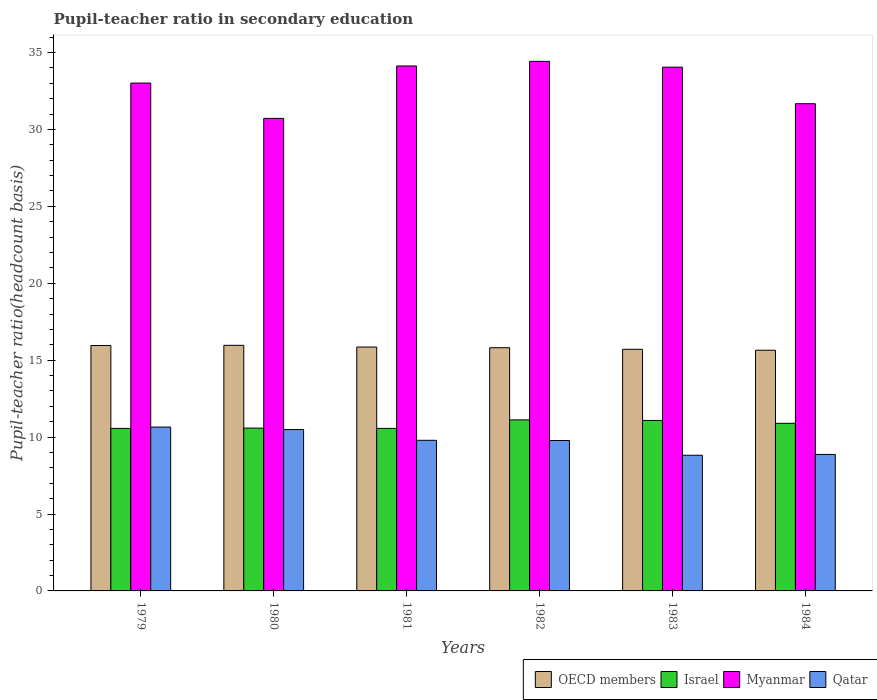Are the number of bars per tick equal to the number of legend labels?
Give a very brief answer. Yes. How many bars are there on the 3rd tick from the left?
Give a very brief answer. 4. What is the label of the 1st group of bars from the left?
Your answer should be compact. 1979. In how many cases, is the number of bars for a given year not equal to the number of legend labels?
Offer a very short reply. 0. What is the pupil-teacher ratio in secondary education in Myanmar in 1983?
Offer a terse response. 34.05. Across all years, what is the maximum pupil-teacher ratio in secondary education in OECD members?
Offer a terse response. 15.97. Across all years, what is the minimum pupil-teacher ratio in secondary education in Israel?
Ensure brevity in your answer.  10.57. What is the total pupil-teacher ratio in secondary education in Myanmar in the graph?
Provide a short and direct response. 198. What is the difference between the pupil-teacher ratio in secondary education in Qatar in 1979 and that in 1980?
Ensure brevity in your answer.  0.16. What is the difference between the pupil-teacher ratio in secondary education in Myanmar in 1983 and the pupil-teacher ratio in secondary education in Israel in 1984?
Provide a succinct answer. 23.15. What is the average pupil-teacher ratio in secondary education in Qatar per year?
Give a very brief answer. 9.73. In the year 1981, what is the difference between the pupil-teacher ratio in secondary education in Qatar and pupil-teacher ratio in secondary education in Myanmar?
Provide a succinct answer. -24.33. What is the ratio of the pupil-teacher ratio in secondary education in Qatar in 1981 to that in 1982?
Give a very brief answer. 1. Is the difference between the pupil-teacher ratio in secondary education in Qatar in 1980 and 1982 greater than the difference between the pupil-teacher ratio in secondary education in Myanmar in 1980 and 1982?
Provide a succinct answer. Yes. What is the difference between the highest and the second highest pupil-teacher ratio in secondary education in OECD members?
Your answer should be compact. 0.01. What is the difference between the highest and the lowest pupil-teacher ratio in secondary education in Myanmar?
Provide a short and direct response. 3.71. In how many years, is the pupil-teacher ratio in secondary education in Myanmar greater than the average pupil-teacher ratio in secondary education in Myanmar taken over all years?
Your answer should be very brief. 4. Is the sum of the pupil-teacher ratio in secondary education in Myanmar in 1980 and 1984 greater than the maximum pupil-teacher ratio in secondary education in OECD members across all years?
Your answer should be very brief. Yes. What does the 1st bar from the left in 1982 represents?
Offer a very short reply. OECD members. What does the 2nd bar from the right in 1983 represents?
Offer a very short reply. Myanmar. How many bars are there?
Offer a very short reply. 24. Are all the bars in the graph horizontal?
Keep it short and to the point. No. How many years are there in the graph?
Your answer should be compact. 6. What is the difference between two consecutive major ticks on the Y-axis?
Offer a very short reply. 5. Does the graph contain grids?
Your answer should be very brief. No. How many legend labels are there?
Offer a terse response. 4. How are the legend labels stacked?
Make the answer very short. Horizontal. What is the title of the graph?
Your answer should be compact. Pupil-teacher ratio in secondary education. What is the label or title of the X-axis?
Offer a terse response. Years. What is the label or title of the Y-axis?
Offer a very short reply. Pupil-teacher ratio(headcount basis). What is the Pupil-teacher ratio(headcount basis) in OECD members in 1979?
Your answer should be compact. 15.95. What is the Pupil-teacher ratio(headcount basis) in Israel in 1979?
Your answer should be compact. 10.57. What is the Pupil-teacher ratio(headcount basis) in Myanmar in 1979?
Make the answer very short. 33.01. What is the Pupil-teacher ratio(headcount basis) in Qatar in 1979?
Keep it short and to the point. 10.65. What is the Pupil-teacher ratio(headcount basis) of OECD members in 1980?
Offer a very short reply. 15.97. What is the Pupil-teacher ratio(headcount basis) in Israel in 1980?
Your response must be concise. 10.59. What is the Pupil-teacher ratio(headcount basis) in Myanmar in 1980?
Give a very brief answer. 30.72. What is the Pupil-teacher ratio(headcount basis) in Qatar in 1980?
Make the answer very short. 10.49. What is the Pupil-teacher ratio(headcount basis) of OECD members in 1981?
Make the answer very short. 15.85. What is the Pupil-teacher ratio(headcount basis) in Israel in 1981?
Your answer should be compact. 10.57. What is the Pupil-teacher ratio(headcount basis) of Myanmar in 1981?
Offer a very short reply. 34.12. What is the Pupil-teacher ratio(headcount basis) of Qatar in 1981?
Provide a succinct answer. 9.79. What is the Pupil-teacher ratio(headcount basis) in OECD members in 1982?
Offer a very short reply. 15.81. What is the Pupil-teacher ratio(headcount basis) of Israel in 1982?
Your response must be concise. 11.12. What is the Pupil-teacher ratio(headcount basis) of Myanmar in 1982?
Make the answer very short. 34.42. What is the Pupil-teacher ratio(headcount basis) of Qatar in 1982?
Your response must be concise. 9.78. What is the Pupil-teacher ratio(headcount basis) in OECD members in 1983?
Offer a terse response. 15.71. What is the Pupil-teacher ratio(headcount basis) in Israel in 1983?
Make the answer very short. 11.08. What is the Pupil-teacher ratio(headcount basis) of Myanmar in 1983?
Make the answer very short. 34.05. What is the Pupil-teacher ratio(headcount basis) in Qatar in 1983?
Ensure brevity in your answer.  8.82. What is the Pupil-teacher ratio(headcount basis) of OECD members in 1984?
Keep it short and to the point. 15.65. What is the Pupil-teacher ratio(headcount basis) of Israel in 1984?
Offer a very short reply. 10.9. What is the Pupil-teacher ratio(headcount basis) of Myanmar in 1984?
Offer a terse response. 31.67. What is the Pupil-teacher ratio(headcount basis) of Qatar in 1984?
Make the answer very short. 8.87. Across all years, what is the maximum Pupil-teacher ratio(headcount basis) of OECD members?
Ensure brevity in your answer.  15.97. Across all years, what is the maximum Pupil-teacher ratio(headcount basis) in Israel?
Provide a succinct answer. 11.12. Across all years, what is the maximum Pupil-teacher ratio(headcount basis) of Myanmar?
Your answer should be very brief. 34.42. Across all years, what is the maximum Pupil-teacher ratio(headcount basis) of Qatar?
Your answer should be very brief. 10.65. Across all years, what is the minimum Pupil-teacher ratio(headcount basis) of OECD members?
Your answer should be very brief. 15.65. Across all years, what is the minimum Pupil-teacher ratio(headcount basis) of Israel?
Offer a terse response. 10.57. Across all years, what is the minimum Pupil-teacher ratio(headcount basis) of Myanmar?
Your answer should be very brief. 30.72. Across all years, what is the minimum Pupil-teacher ratio(headcount basis) of Qatar?
Provide a succinct answer. 8.82. What is the total Pupil-teacher ratio(headcount basis) of OECD members in the graph?
Make the answer very short. 94.94. What is the total Pupil-teacher ratio(headcount basis) in Israel in the graph?
Your answer should be compact. 64.81. What is the total Pupil-teacher ratio(headcount basis) of Myanmar in the graph?
Your answer should be very brief. 198. What is the total Pupil-teacher ratio(headcount basis) in Qatar in the graph?
Offer a very short reply. 58.4. What is the difference between the Pupil-teacher ratio(headcount basis) in OECD members in 1979 and that in 1980?
Offer a terse response. -0.01. What is the difference between the Pupil-teacher ratio(headcount basis) in Israel in 1979 and that in 1980?
Your response must be concise. -0.02. What is the difference between the Pupil-teacher ratio(headcount basis) in Myanmar in 1979 and that in 1980?
Provide a short and direct response. 2.3. What is the difference between the Pupil-teacher ratio(headcount basis) in Qatar in 1979 and that in 1980?
Make the answer very short. 0.16. What is the difference between the Pupil-teacher ratio(headcount basis) of OECD members in 1979 and that in 1981?
Ensure brevity in your answer.  0.1. What is the difference between the Pupil-teacher ratio(headcount basis) in Israel in 1979 and that in 1981?
Your answer should be very brief. -0. What is the difference between the Pupil-teacher ratio(headcount basis) of Myanmar in 1979 and that in 1981?
Your response must be concise. -1.11. What is the difference between the Pupil-teacher ratio(headcount basis) of Qatar in 1979 and that in 1981?
Ensure brevity in your answer.  0.86. What is the difference between the Pupil-teacher ratio(headcount basis) in OECD members in 1979 and that in 1982?
Your answer should be compact. 0.14. What is the difference between the Pupil-teacher ratio(headcount basis) in Israel in 1979 and that in 1982?
Offer a very short reply. -0.55. What is the difference between the Pupil-teacher ratio(headcount basis) of Myanmar in 1979 and that in 1982?
Keep it short and to the point. -1.41. What is the difference between the Pupil-teacher ratio(headcount basis) in Qatar in 1979 and that in 1982?
Ensure brevity in your answer.  0.88. What is the difference between the Pupil-teacher ratio(headcount basis) of OECD members in 1979 and that in 1983?
Provide a succinct answer. 0.25. What is the difference between the Pupil-teacher ratio(headcount basis) of Israel in 1979 and that in 1983?
Your response must be concise. -0.52. What is the difference between the Pupil-teacher ratio(headcount basis) in Myanmar in 1979 and that in 1983?
Make the answer very short. -1.03. What is the difference between the Pupil-teacher ratio(headcount basis) in Qatar in 1979 and that in 1983?
Make the answer very short. 1.83. What is the difference between the Pupil-teacher ratio(headcount basis) of OECD members in 1979 and that in 1984?
Your response must be concise. 0.31. What is the difference between the Pupil-teacher ratio(headcount basis) in Israel in 1979 and that in 1984?
Your answer should be very brief. -0.33. What is the difference between the Pupil-teacher ratio(headcount basis) of Myanmar in 1979 and that in 1984?
Your answer should be compact. 1.34. What is the difference between the Pupil-teacher ratio(headcount basis) in Qatar in 1979 and that in 1984?
Ensure brevity in your answer.  1.78. What is the difference between the Pupil-teacher ratio(headcount basis) in OECD members in 1980 and that in 1981?
Ensure brevity in your answer.  0.11. What is the difference between the Pupil-teacher ratio(headcount basis) of Israel in 1980 and that in 1981?
Provide a short and direct response. 0.02. What is the difference between the Pupil-teacher ratio(headcount basis) in Myanmar in 1980 and that in 1981?
Offer a terse response. -3.41. What is the difference between the Pupil-teacher ratio(headcount basis) of Qatar in 1980 and that in 1981?
Your response must be concise. 0.7. What is the difference between the Pupil-teacher ratio(headcount basis) of OECD members in 1980 and that in 1982?
Provide a succinct answer. 0.15. What is the difference between the Pupil-teacher ratio(headcount basis) in Israel in 1980 and that in 1982?
Your answer should be very brief. -0.53. What is the difference between the Pupil-teacher ratio(headcount basis) of Myanmar in 1980 and that in 1982?
Your answer should be compact. -3.71. What is the difference between the Pupil-teacher ratio(headcount basis) in Qatar in 1980 and that in 1982?
Ensure brevity in your answer.  0.71. What is the difference between the Pupil-teacher ratio(headcount basis) in OECD members in 1980 and that in 1983?
Your answer should be compact. 0.26. What is the difference between the Pupil-teacher ratio(headcount basis) of Israel in 1980 and that in 1983?
Give a very brief answer. -0.5. What is the difference between the Pupil-teacher ratio(headcount basis) in Myanmar in 1980 and that in 1983?
Provide a succinct answer. -3.33. What is the difference between the Pupil-teacher ratio(headcount basis) in Qatar in 1980 and that in 1983?
Ensure brevity in your answer.  1.67. What is the difference between the Pupil-teacher ratio(headcount basis) of OECD members in 1980 and that in 1984?
Your response must be concise. 0.32. What is the difference between the Pupil-teacher ratio(headcount basis) in Israel in 1980 and that in 1984?
Provide a succinct answer. -0.31. What is the difference between the Pupil-teacher ratio(headcount basis) of Myanmar in 1980 and that in 1984?
Offer a terse response. -0.95. What is the difference between the Pupil-teacher ratio(headcount basis) in Qatar in 1980 and that in 1984?
Make the answer very short. 1.62. What is the difference between the Pupil-teacher ratio(headcount basis) in OECD members in 1981 and that in 1982?
Ensure brevity in your answer.  0.04. What is the difference between the Pupil-teacher ratio(headcount basis) in Israel in 1981 and that in 1982?
Make the answer very short. -0.55. What is the difference between the Pupil-teacher ratio(headcount basis) of Myanmar in 1981 and that in 1982?
Provide a short and direct response. -0.3. What is the difference between the Pupil-teacher ratio(headcount basis) in Qatar in 1981 and that in 1982?
Ensure brevity in your answer.  0.01. What is the difference between the Pupil-teacher ratio(headcount basis) of OECD members in 1981 and that in 1983?
Your answer should be compact. 0.15. What is the difference between the Pupil-teacher ratio(headcount basis) of Israel in 1981 and that in 1983?
Keep it short and to the point. -0.52. What is the difference between the Pupil-teacher ratio(headcount basis) of Myanmar in 1981 and that in 1983?
Offer a very short reply. 0.08. What is the difference between the Pupil-teacher ratio(headcount basis) in Qatar in 1981 and that in 1983?
Give a very brief answer. 0.97. What is the difference between the Pupil-teacher ratio(headcount basis) of OECD members in 1981 and that in 1984?
Your answer should be very brief. 0.21. What is the difference between the Pupil-teacher ratio(headcount basis) in Israel in 1981 and that in 1984?
Your answer should be very brief. -0.33. What is the difference between the Pupil-teacher ratio(headcount basis) in Myanmar in 1981 and that in 1984?
Make the answer very short. 2.45. What is the difference between the Pupil-teacher ratio(headcount basis) of Qatar in 1981 and that in 1984?
Your answer should be very brief. 0.92. What is the difference between the Pupil-teacher ratio(headcount basis) in OECD members in 1982 and that in 1983?
Offer a terse response. 0.1. What is the difference between the Pupil-teacher ratio(headcount basis) of Israel in 1982 and that in 1983?
Your answer should be very brief. 0.04. What is the difference between the Pupil-teacher ratio(headcount basis) of Myanmar in 1982 and that in 1983?
Make the answer very short. 0.38. What is the difference between the Pupil-teacher ratio(headcount basis) in Qatar in 1982 and that in 1983?
Provide a succinct answer. 0.96. What is the difference between the Pupil-teacher ratio(headcount basis) in OECD members in 1982 and that in 1984?
Give a very brief answer. 0.16. What is the difference between the Pupil-teacher ratio(headcount basis) of Israel in 1982 and that in 1984?
Your answer should be compact. 0.22. What is the difference between the Pupil-teacher ratio(headcount basis) in Myanmar in 1982 and that in 1984?
Your response must be concise. 2.75. What is the difference between the Pupil-teacher ratio(headcount basis) in Qatar in 1982 and that in 1984?
Ensure brevity in your answer.  0.9. What is the difference between the Pupil-teacher ratio(headcount basis) of OECD members in 1983 and that in 1984?
Offer a very short reply. 0.06. What is the difference between the Pupil-teacher ratio(headcount basis) in Israel in 1983 and that in 1984?
Provide a short and direct response. 0.19. What is the difference between the Pupil-teacher ratio(headcount basis) in Myanmar in 1983 and that in 1984?
Your response must be concise. 2.38. What is the difference between the Pupil-teacher ratio(headcount basis) of Qatar in 1983 and that in 1984?
Offer a terse response. -0.05. What is the difference between the Pupil-teacher ratio(headcount basis) of OECD members in 1979 and the Pupil-teacher ratio(headcount basis) of Israel in 1980?
Your response must be concise. 5.37. What is the difference between the Pupil-teacher ratio(headcount basis) of OECD members in 1979 and the Pupil-teacher ratio(headcount basis) of Myanmar in 1980?
Your answer should be very brief. -14.77. What is the difference between the Pupil-teacher ratio(headcount basis) in OECD members in 1979 and the Pupil-teacher ratio(headcount basis) in Qatar in 1980?
Provide a succinct answer. 5.46. What is the difference between the Pupil-teacher ratio(headcount basis) in Israel in 1979 and the Pupil-teacher ratio(headcount basis) in Myanmar in 1980?
Your response must be concise. -20.15. What is the difference between the Pupil-teacher ratio(headcount basis) in Israel in 1979 and the Pupil-teacher ratio(headcount basis) in Qatar in 1980?
Offer a terse response. 0.08. What is the difference between the Pupil-teacher ratio(headcount basis) in Myanmar in 1979 and the Pupil-teacher ratio(headcount basis) in Qatar in 1980?
Offer a terse response. 22.52. What is the difference between the Pupil-teacher ratio(headcount basis) of OECD members in 1979 and the Pupil-teacher ratio(headcount basis) of Israel in 1981?
Ensure brevity in your answer.  5.39. What is the difference between the Pupil-teacher ratio(headcount basis) in OECD members in 1979 and the Pupil-teacher ratio(headcount basis) in Myanmar in 1981?
Give a very brief answer. -18.17. What is the difference between the Pupil-teacher ratio(headcount basis) in OECD members in 1979 and the Pupil-teacher ratio(headcount basis) in Qatar in 1981?
Your answer should be compact. 6.16. What is the difference between the Pupil-teacher ratio(headcount basis) of Israel in 1979 and the Pupil-teacher ratio(headcount basis) of Myanmar in 1981?
Offer a terse response. -23.56. What is the difference between the Pupil-teacher ratio(headcount basis) of Israel in 1979 and the Pupil-teacher ratio(headcount basis) of Qatar in 1981?
Make the answer very short. 0.77. What is the difference between the Pupil-teacher ratio(headcount basis) of Myanmar in 1979 and the Pupil-teacher ratio(headcount basis) of Qatar in 1981?
Your answer should be compact. 23.22. What is the difference between the Pupil-teacher ratio(headcount basis) in OECD members in 1979 and the Pupil-teacher ratio(headcount basis) in Israel in 1982?
Your response must be concise. 4.84. What is the difference between the Pupil-teacher ratio(headcount basis) in OECD members in 1979 and the Pupil-teacher ratio(headcount basis) in Myanmar in 1982?
Your answer should be very brief. -18.47. What is the difference between the Pupil-teacher ratio(headcount basis) of OECD members in 1979 and the Pupil-teacher ratio(headcount basis) of Qatar in 1982?
Your response must be concise. 6.18. What is the difference between the Pupil-teacher ratio(headcount basis) of Israel in 1979 and the Pupil-teacher ratio(headcount basis) of Myanmar in 1982?
Ensure brevity in your answer.  -23.86. What is the difference between the Pupil-teacher ratio(headcount basis) of Israel in 1979 and the Pupil-teacher ratio(headcount basis) of Qatar in 1982?
Provide a succinct answer. 0.79. What is the difference between the Pupil-teacher ratio(headcount basis) of Myanmar in 1979 and the Pupil-teacher ratio(headcount basis) of Qatar in 1982?
Your answer should be compact. 23.24. What is the difference between the Pupil-teacher ratio(headcount basis) of OECD members in 1979 and the Pupil-teacher ratio(headcount basis) of Israel in 1983?
Provide a succinct answer. 4.87. What is the difference between the Pupil-teacher ratio(headcount basis) of OECD members in 1979 and the Pupil-teacher ratio(headcount basis) of Myanmar in 1983?
Provide a short and direct response. -18.09. What is the difference between the Pupil-teacher ratio(headcount basis) in OECD members in 1979 and the Pupil-teacher ratio(headcount basis) in Qatar in 1983?
Keep it short and to the point. 7.13. What is the difference between the Pupil-teacher ratio(headcount basis) of Israel in 1979 and the Pupil-teacher ratio(headcount basis) of Myanmar in 1983?
Make the answer very short. -23.48. What is the difference between the Pupil-teacher ratio(headcount basis) in Israel in 1979 and the Pupil-teacher ratio(headcount basis) in Qatar in 1983?
Offer a terse response. 1.75. What is the difference between the Pupil-teacher ratio(headcount basis) of Myanmar in 1979 and the Pupil-teacher ratio(headcount basis) of Qatar in 1983?
Offer a terse response. 24.2. What is the difference between the Pupil-teacher ratio(headcount basis) of OECD members in 1979 and the Pupil-teacher ratio(headcount basis) of Israel in 1984?
Give a very brief answer. 5.06. What is the difference between the Pupil-teacher ratio(headcount basis) of OECD members in 1979 and the Pupil-teacher ratio(headcount basis) of Myanmar in 1984?
Offer a very short reply. -15.72. What is the difference between the Pupil-teacher ratio(headcount basis) in OECD members in 1979 and the Pupil-teacher ratio(headcount basis) in Qatar in 1984?
Provide a short and direct response. 7.08. What is the difference between the Pupil-teacher ratio(headcount basis) in Israel in 1979 and the Pupil-teacher ratio(headcount basis) in Myanmar in 1984?
Your answer should be compact. -21.11. What is the difference between the Pupil-teacher ratio(headcount basis) of Israel in 1979 and the Pupil-teacher ratio(headcount basis) of Qatar in 1984?
Your answer should be very brief. 1.69. What is the difference between the Pupil-teacher ratio(headcount basis) of Myanmar in 1979 and the Pupil-teacher ratio(headcount basis) of Qatar in 1984?
Ensure brevity in your answer.  24.14. What is the difference between the Pupil-teacher ratio(headcount basis) in OECD members in 1980 and the Pupil-teacher ratio(headcount basis) in Israel in 1981?
Offer a very short reply. 5.4. What is the difference between the Pupil-teacher ratio(headcount basis) in OECD members in 1980 and the Pupil-teacher ratio(headcount basis) in Myanmar in 1981?
Ensure brevity in your answer.  -18.16. What is the difference between the Pupil-teacher ratio(headcount basis) of OECD members in 1980 and the Pupil-teacher ratio(headcount basis) of Qatar in 1981?
Give a very brief answer. 6.17. What is the difference between the Pupil-teacher ratio(headcount basis) in Israel in 1980 and the Pupil-teacher ratio(headcount basis) in Myanmar in 1981?
Offer a very short reply. -23.54. What is the difference between the Pupil-teacher ratio(headcount basis) of Israel in 1980 and the Pupil-teacher ratio(headcount basis) of Qatar in 1981?
Offer a very short reply. 0.79. What is the difference between the Pupil-teacher ratio(headcount basis) in Myanmar in 1980 and the Pupil-teacher ratio(headcount basis) in Qatar in 1981?
Offer a terse response. 20.93. What is the difference between the Pupil-teacher ratio(headcount basis) of OECD members in 1980 and the Pupil-teacher ratio(headcount basis) of Israel in 1982?
Provide a succinct answer. 4.85. What is the difference between the Pupil-teacher ratio(headcount basis) in OECD members in 1980 and the Pupil-teacher ratio(headcount basis) in Myanmar in 1982?
Your answer should be compact. -18.46. What is the difference between the Pupil-teacher ratio(headcount basis) in OECD members in 1980 and the Pupil-teacher ratio(headcount basis) in Qatar in 1982?
Provide a short and direct response. 6.19. What is the difference between the Pupil-teacher ratio(headcount basis) of Israel in 1980 and the Pupil-teacher ratio(headcount basis) of Myanmar in 1982?
Offer a very short reply. -23.84. What is the difference between the Pupil-teacher ratio(headcount basis) in Israel in 1980 and the Pupil-teacher ratio(headcount basis) in Qatar in 1982?
Provide a succinct answer. 0.81. What is the difference between the Pupil-teacher ratio(headcount basis) of Myanmar in 1980 and the Pupil-teacher ratio(headcount basis) of Qatar in 1982?
Your response must be concise. 20.94. What is the difference between the Pupil-teacher ratio(headcount basis) of OECD members in 1980 and the Pupil-teacher ratio(headcount basis) of Israel in 1983?
Ensure brevity in your answer.  4.88. What is the difference between the Pupil-teacher ratio(headcount basis) in OECD members in 1980 and the Pupil-teacher ratio(headcount basis) in Myanmar in 1983?
Keep it short and to the point. -18.08. What is the difference between the Pupil-teacher ratio(headcount basis) of OECD members in 1980 and the Pupil-teacher ratio(headcount basis) of Qatar in 1983?
Your response must be concise. 7.15. What is the difference between the Pupil-teacher ratio(headcount basis) of Israel in 1980 and the Pupil-teacher ratio(headcount basis) of Myanmar in 1983?
Offer a very short reply. -23.46. What is the difference between the Pupil-teacher ratio(headcount basis) of Israel in 1980 and the Pupil-teacher ratio(headcount basis) of Qatar in 1983?
Keep it short and to the point. 1.77. What is the difference between the Pupil-teacher ratio(headcount basis) in Myanmar in 1980 and the Pupil-teacher ratio(headcount basis) in Qatar in 1983?
Your answer should be very brief. 21.9. What is the difference between the Pupil-teacher ratio(headcount basis) of OECD members in 1980 and the Pupil-teacher ratio(headcount basis) of Israel in 1984?
Provide a short and direct response. 5.07. What is the difference between the Pupil-teacher ratio(headcount basis) in OECD members in 1980 and the Pupil-teacher ratio(headcount basis) in Myanmar in 1984?
Your answer should be compact. -15.71. What is the difference between the Pupil-teacher ratio(headcount basis) in OECD members in 1980 and the Pupil-teacher ratio(headcount basis) in Qatar in 1984?
Offer a terse response. 7.09. What is the difference between the Pupil-teacher ratio(headcount basis) of Israel in 1980 and the Pupil-teacher ratio(headcount basis) of Myanmar in 1984?
Provide a succinct answer. -21.09. What is the difference between the Pupil-teacher ratio(headcount basis) in Israel in 1980 and the Pupil-teacher ratio(headcount basis) in Qatar in 1984?
Ensure brevity in your answer.  1.71. What is the difference between the Pupil-teacher ratio(headcount basis) of Myanmar in 1980 and the Pupil-teacher ratio(headcount basis) of Qatar in 1984?
Provide a succinct answer. 21.85. What is the difference between the Pupil-teacher ratio(headcount basis) in OECD members in 1981 and the Pupil-teacher ratio(headcount basis) in Israel in 1982?
Provide a short and direct response. 4.74. What is the difference between the Pupil-teacher ratio(headcount basis) of OECD members in 1981 and the Pupil-teacher ratio(headcount basis) of Myanmar in 1982?
Give a very brief answer. -18.57. What is the difference between the Pupil-teacher ratio(headcount basis) in OECD members in 1981 and the Pupil-teacher ratio(headcount basis) in Qatar in 1982?
Your answer should be compact. 6.08. What is the difference between the Pupil-teacher ratio(headcount basis) of Israel in 1981 and the Pupil-teacher ratio(headcount basis) of Myanmar in 1982?
Your answer should be compact. -23.86. What is the difference between the Pupil-teacher ratio(headcount basis) of Israel in 1981 and the Pupil-teacher ratio(headcount basis) of Qatar in 1982?
Make the answer very short. 0.79. What is the difference between the Pupil-teacher ratio(headcount basis) in Myanmar in 1981 and the Pupil-teacher ratio(headcount basis) in Qatar in 1982?
Offer a terse response. 24.35. What is the difference between the Pupil-teacher ratio(headcount basis) in OECD members in 1981 and the Pupil-teacher ratio(headcount basis) in Israel in 1983?
Offer a very short reply. 4.77. What is the difference between the Pupil-teacher ratio(headcount basis) of OECD members in 1981 and the Pupil-teacher ratio(headcount basis) of Myanmar in 1983?
Make the answer very short. -18.19. What is the difference between the Pupil-teacher ratio(headcount basis) of OECD members in 1981 and the Pupil-teacher ratio(headcount basis) of Qatar in 1983?
Provide a succinct answer. 7.04. What is the difference between the Pupil-teacher ratio(headcount basis) of Israel in 1981 and the Pupil-teacher ratio(headcount basis) of Myanmar in 1983?
Your answer should be very brief. -23.48. What is the difference between the Pupil-teacher ratio(headcount basis) in Israel in 1981 and the Pupil-teacher ratio(headcount basis) in Qatar in 1983?
Your answer should be compact. 1.75. What is the difference between the Pupil-teacher ratio(headcount basis) of Myanmar in 1981 and the Pupil-teacher ratio(headcount basis) of Qatar in 1983?
Give a very brief answer. 25.3. What is the difference between the Pupil-teacher ratio(headcount basis) of OECD members in 1981 and the Pupil-teacher ratio(headcount basis) of Israel in 1984?
Your response must be concise. 4.96. What is the difference between the Pupil-teacher ratio(headcount basis) of OECD members in 1981 and the Pupil-teacher ratio(headcount basis) of Myanmar in 1984?
Your response must be concise. -15.82. What is the difference between the Pupil-teacher ratio(headcount basis) of OECD members in 1981 and the Pupil-teacher ratio(headcount basis) of Qatar in 1984?
Keep it short and to the point. 6.98. What is the difference between the Pupil-teacher ratio(headcount basis) in Israel in 1981 and the Pupil-teacher ratio(headcount basis) in Myanmar in 1984?
Provide a short and direct response. -21.11. What is the difference between the Pupil-teacher ratio(headcount basis) of Israel in 1981 and the Pupil-teacher ratio(headcount basis) of Qatar in 1984?
Provide a short and direct response. 1.69. What is the difference between the Pupil-teacher ratio(headcount basis) in Myanmar in 1981 and the Pupil-teacher ratio(headcount basis) in Qatar in 1984?
Your answer should be compact. 25.25. What is the difference between the Pupil-teacher ratio(headcount basis) of OECD members in 1982 and the Pupil-teacher ratio(headcount basis) of Israel in 1983?
Offer a terse response. 4.73. What is the difference between the Pupil-teacher ratio(headcount basis) in OECD members in 1982 and the Pupil-teacher ratio(headcount basis) in Myanmar in 1983?
Give a very brief answer. -18.24. What is the difference between the Pupil-teacher ratio(headcount basis) in OECD members in 1982 and the Pupil-teacher ratio(headcount basis) in Qatar in 1983?
Ensure brevity in your answer.  6.99. What is the difference between the Pupil-teacher ratio(headcount basis) in Israel in 1982 and the Pupil-teacher ratio(headcount basis) in Myanmar in 1983?
Offer a very short reply. -22.93. What is the difference between the Pupil-teacher ratio(headcount basis) in Israel in 1982 and the Pupil-teacher ratio(headcount basis) in Qatar in 1983?
Your answer should be very brief. 2.3. What is the difference between the Pupil-teacher ratio(headcount basis) of Myanmar in 1982 and the Pupil-teacher ratio(headcount basis) of Qatar in 1983?
Your response must be concise. 25.61. What is the difference between the Pupil-teacher ratio(headcount basis) of OECD members in 1982 and the Pupil-teacher ratio(headcount basis) of Israel in 1984?
Offer a very short reply. 4.91. What is the difference between the Pupil-teacher ratio(headcount basis) in OECD members in 1982 and the Pupil-teacher ratio(headcount basis) in Myanmar in 1984?
Your response must be concise. -15.86. What is the difference between the Pupil-teacher ratio(headcount basis) of OECD members in 1982 and the Pupil-teacher ratio(headcount basis) of Qatar in 1984?
Your answer should be very brief. 6.94. What is the difference between the Pupil-teacher ratio(headcount basis) of Israel in 1982 and the Pupil-teacher ratio(headcount basis) of Myanmar in 1984?
Your answer should be very brief. -20.55. What is the difference between the Pupil-teacher ratio(headcount basis) in Israel in 1982 and the Pupil-teacher ratio(headcount basis) in Qatar in 1984?
Give a very brief answer. 2.25. What is the difference between the Pupil-teacher ratio(headcount basis) in Myanmar in 1982 and the Pupil-teacher ratio(headcount basis) in Qatar in 1984?
Your response must be concise. 25.55. What is the difference between the Pupil-teacher ratio(headcount basis) of OECD members in 1983 and the Pupil-teacher ratio(headcount basis) of Israel in 1984?
Give a very brief answer. 4.81. What is the difference between the Pupil-teacher ratio(headcount basis) in OECD members in 1983 and the Pupil-teacher ratio(headcount basis) in Myanmar in 1984?
Make the answer very short. -15.96. What is the difference between the Pupil-teacher ratio(headcount basis) in OECD members in 1983 and the Pupil-teacher ratio(headcount basis) in Qatar in 1984?
Give a very brief answer. 6.84. What is the difference between the Pupil-teacher ratio(headcount basis) of Israel in 1983 and the Pupil-teacher ratio(headcount basis) of Myanmar in 1984?
Your answer should be very brief. -20.59. What is the difference between the Pupil-teacher ratio(headcount basis) of Israel in 1983 and the Pupil-teacher ratio(headcount basis) of Qatar in 1984?
Offer a terse response. 2.21. What is the difference between the Pupil-teacher ratio(headcount basis) of Myanmar in 1983 and the Pupil-teacher ratio(headcount basis) of Qatar in 1984?
Your answer should be very brief. 25.18. What is the average Pupil-teacher ratio(headcount basis) in OECD members per year?
Keep it short and to the point. 15.82. What is the average Pupil-teacher ratio(headcount basis) of Israel per year?
Offer a terse response. 10.8. What is the average Pupil-teacher ratio(headcount basis) in Qatar per year?
Ensure brevity in your answer.  9.73. In the year 1979, what is the difference between the Pupil-teacher ratio(headcount basis) in OECD members and Pupil-teacher ratio(headcount basis) in Israel?
Your answer should be very brief. 5.39. In the year 1979, what is the difference between the Pupil-teacher ratio(headcount basis) in OECD members and Pupil-teacher ratio(headcount basis) in Myanmar?
Provide a succinct answer. -17.06. In the year 1979, what is the difference between the Pupil-teacher ratio(headcount basis) of OECD members and Pupil-teacher ratio(headcount basis) of Qatar?
Your answer should be very brief. 5.3. In the year 1979, what is the difference between the Pupil-teacher ratio(headcount basis) of Israel and Pupil-teacher ratio(headcount basis) of Myanmar?
Offer a terse response. -22.45. In the year 1979, what is the difference between the Pupil-teacher ratio(headcount basis) in Israel and Pupil-teacher ratio(headcount basis) in Qatar?
Keep it short and to the point. -0.09. In the year 1979, what is the difference between the Pupil-teacher ratio(headcount basis) in Myanmar and Pupil-teacher ratio(headcount basis) in Qatar?
Give a very brief answer. 22.36. In the year 1980, what is the difference between the Pupil-teacher ratio(headcount basis) of OECD members and Pupil-teacher ratio(headcount basis) of Israel?
Provide a succinct answer. 5.38. In the year 1980, what is the difference between the Pupil-teacher ratio(headcount basis) of OECD members and Pupil-teacher ratio(headcount basis) of Myanmar?
Your response must be concise. -14.75. In the year 1980, what is the difference between the Pupil-teacher ratio(headcount basis) of OECD members and Pupil-teacher ratio(headcount basis) of Qatar?
Your answer should be very brief. 5.48. In the year 1980, what is the difference between the Pupil-teacher ratio(headcount basis) in Israel and Pupil-teacher ratio(headcount basis) in Myanmar?
Provide a short and direct response. -20.13. In the year 1980, what is the difference between the Pupil-teacher ratio(headcount basis) in Israel and Pupil-teacher ratio(headcount basis) in Qatar?
Ensure brevity in your answer.  0.1. In the year 1980, what is the difference between the Pupil-teacher ratio(headcount basis) in Myanmar and Pupil-teacher ratio(headcount basis) in Qatar?
Your answer should be compact. 20.23. In the year 1981, what is the difference between the Pupil-teacher ratio(headcount basis) in OECD members and Pupil-teacher ratio(headcount basis) in Israel?
Ensure brevity in your answer.  5.29. In the year 1981, what is the difference between the Pupil-teacher ratio(headcount basis) in OECD members and Pupil-teacher ratio(headcount basis) in Myanmar?
Your response must be concise. -18.27. In the year 1981, what is the difference between the Pupil-teacher ratio(headcount basis) in OECD members and Pupil-teacher ratio(headcount basis) in Qatar?
Make the answer very short. 6.06. In the year 1981, what is the difference between the Pupil-teacher ratio(headcount basis) in Israel and Pupil-teacher ratio(headcount basis) in Myanmar?
Make the answer very short. -23.56. In the year 1981, what is the difference between the Pupil-teacher ratio(headcount basis) of Israel and Pupil-teacher ratio(headcount basis) of Qatar?
Keep it short and to the point. 0.78. In the year 1981, what is the difference between the Pupil-teacher ratio(headcount basis) in Myanmar and Pupil-teacher ratio(headcount basis) in Qatar?
Your response must be concise. 24.33. In the year 1982, what is the difference between the Pupil-teacher ratio(headcount basis) in OECD members and Pupil-teacher ratio(headcount basis) in Israel?
Provide a succinct answer. 4.69. In the year 1982, what is the difference between the Pupil-teacher ratio(headcount basis) of OECD members and Pupil-teacher ratio(headcount basis) of Myanmar?
Give a very brief answer. -18.61. In the year 1982, what is the difference between the Pupil-teacher ratio(headcount basis) of OECD members and Pupil-teacher ratio(headcount basis) of Qatar?
Your answer should be compact. 6.03. In the year 1982, what is the difference between the Pupil-teacher ratio(headcount basis) in Israel and Pupil-teacher ratio(headcount basis) in Myanmar?
Your answer should be very brief. -23.31. In the year 1982, what is the difference between the Pupil-teacher ratio(headcount basis) in Israel and Pupil-teacher ratio(headcount basis) in Qatar?
Offer a very short reply. 1.34. In the year 1982, what is the difference between the Pupil-teacher ratio(headcount basis) of Myanmar and Pupil-teacher ratio(headcount basis) of Qatar?
Offer a very short reply. 24.65. In the year 1983, what is the difference between the Pupil-teacher ratio(headcount basis) of OECD members and Pupil-teacher ratio(headcount basis) of Israel?
Your response must be concise. 4.63. In the year 1983, what is the difference between the Pupil-teacher ratio(headcount basis) in OECD members and Pupil-teacher ratio(headcount basis) in Myanmar?
Give a very brief answer. -18.34. In the year 1983, what is the difference between the Pupil-teacher ratio(headcount basis) in OECD members and Pupil-teacher ratio(headcount basis) in Qatar?
Your answer should be very brief. 6.89. In the year 1983, what is the difference between the Pupil-teacher ratio(headcount basis) in Israel and Pupil-teacher ratio(headcount basis) in Myanmar?
Your answer should be very brief. -22.97. In the year 1983, what is the difference between the Pupil-teacher ratio(headcount basis) of Israel and Pupil-teacher ratio(headcount basis) of Qatar?
Keep it short and to the point. 2.26. In the year 1983, what is the difference between the Pupil-teacher ratio(headcount basis) in Myanmar and Pupil-teacher ratio(headcount basis) in Qatar?
Your answer should be very brief. 25.23. In the year 1984, what is the difference between the Pupil-teacher ratio(headcount basis) in OECD members and Pupil-teacher ratio(headcount basis) in Israel?
Your answer should be very brief. 4.75. In the year 1984, what is the difference between the Pupil-teacher ratio(headcount basis) of OECD members and Pupil-teacher ratio(headcount basis) of Myanmar?
Offer a terse response. -16.03. In the year 1984, what is the difference between the Pupil-teacher ratio(headcount basis) of OECD members and Pupil-teacher ratio(headcount basis) of Qatar?
Your answer should be very brief. 6.77. In the year 1984, what is the difference between the Pupil-teacher ratio(headcount basis) in Israel and Pupil-teacher ratio(headcount basis) in Myanmar?
Keep it short and to the point. -20.78. In the year 1984, what is the difference between the Pupil-teacher ratio(headcount basis) in Israel and Pupil-teacher ratio(headcount basis) in Qatar?
Your answer should be compact. 2.02. In the year 1984, what is the difference between the Pupil-teacher ratio(headcount basis) of Myanmar and Pupil-teacher ratio(headcount basis) of Qatar?
Your answer should be very brief. 22.8. What is the ratio of the Pupil-teacher ratio(headcount basis) in Myanmar in 1979 to that in 1980?
Give a very brief answer. 1.07. What is the ratio of the Pupil-teacher ratio(headcount basis) of Qatar in 1979 to that in 1980?
Your answer should be very brief. 1.02. What is the ratio of the Pupil-teacher ratio(headcount basis) in Myanmar in 1979 to that in 1981?
Your response must be concise. 0.97. What is the ratio of the Pupil-teacher ratio(headcount basis) of Qatar in 1979 to that in 1981?
Provide a short and direct response. 1.09. What is the ratio of the Pupil-teacher ratio(headcount basis) in Israel in 1979 to that in 1982?
Offer a very short reply. 0.95. What is the ratio of the Pupil-teacher ratio(headcount basis) in Qatar in 1979 to that in 1982?
Ensure brevity in your answer.  1.09. What is the ratio of the Pupil-teacher ratio(headcount basis) of OECD members in 1979 to that in 1983?
Your answer should be very brief. 1.02. What is the ratio of the Pupil-teacher ratio(headcount basis) in Israel in 1979 to that in 1983?
Ensure brevity in your answer.  0.95. What is the ratio of the Pupil-teacher ratio(headcount basis) of Myanmar in 1979 to that in 1983?
Provide a succinct answer. 0.97. What is the ratio of the Pupil-teacher ratio(headcount basis) of Qatar in 1979 to that in 1983?
Provide a succinct answer. 1.21. What is the ratio of the Pupil-teacher ratio(headcount basis) of OECD members in 1979 to that in 1984?
Your response must be concise. 1.02. What is the ratio of the Pupil-teacher ratio(headcount basis) of Israel in 1979 to that in 1984?
Offer a very short reply. 0.97. What is the ratio of the Pupil-teacher ratio(headcount basis) of Myanmar in 1979 to that in 1984?
Keep it short and to the point. 1.04. What is the ratio of the Pupil-teacher ratio(headcount basis) in Qatar in 1979 to that in 1984?
Make the answer very short. 1.2. What is the ratio of the Pupil-teacher ratio(headcount basis) in Israel in 1980 to that in 1981?
Your answer should be very brief. 1. What is the ratio of the Pupil-teacher ratio(headcount basis) of Myanmar in 1980 to that in 1981?
Ensure brevity in your answer.  0.9. What is the ratio of the Pupil-teacher ratio(headcount basis) of Qatar in 1980 to that in 1981?
Offer a terse response. 1.07. What is the ratio of the Pupil-teacher ratio(headcount basis) of OECD members in 1980 to that in 1982?
Keep it short and to the point. 1.01. What is the ratio of the Pupil-teacher ratio(headcount basis) in Israel in 1980 to that in 1982?
Give a very brief answer. 0.95. What is the ratio of the Pupil-teacher ratio(headcount basis) in Myanmar in 1980 to that in 1982?
Offer a terse response. 0.89. What is the ratio of the Pupil-teacher ratio(headcount basis) of Qatar in 1980 to that in 1982?
Ensure brevity in your answer.  1.07. What is the ratio of the Pupil-teacher ratio(headcount basis) of OECD members in 1980 to that in 1983?
Ensure brevity in your answer.  1.02. What is the ratio of the Pupil-teacher ratio(headcount basis) in Israel in 1980 to that in 1983?
Offer a terse response. 0.96. What is the ratio of the Pupil-teacher ratio(headcount basis) of Myanmar in 1980 to that in 1983?
Ensure brevity in your answer.  0.9. What is the ratio of the Pupil-teacher ratio(headcount basis) of Qatar in 1980 to that in 1983?
Provide a short and direct response. 1.19. What is the ratio of the Pupil-teacher ratio(headcount basis) of OECD members in 1980 to that in 1984?
Offer a very short reply. 1.02. What is the ratio of the Pupil-teacher ratio(headcount basis) in Israel in 1980 to that in 1984?
Provide a succinct answer. 0.97. What is the ratio of the Pupil-teacher ratio(headcount basis) in Myanmar in 1980 to that in 1984?
Ensure brevity in your answer.  0.97. What is the ratio of the Pupil-teacher ratio(headcount basis) in Qatar in 1980 to that in 1984?
Your answer should be very brief. 1.18. What is the ratio of the Pupil-teacher ratio(headcount basis) in Israel in 1981 to that in 1982?
Your response must be concise. 0.95. What is the ratio of the Pupil-teacher ratio(headcount basis) in OECD members in 1981 to that in 1983?
Offer a terse response. 1.01. What is the ratio of the Pupil-teacher ratio(headcount basis) of Israel in 1981 to that in 1983?
Provide a succinct answer. 0.95. What is the ratio of the Pupil-teacher ratio(headcount basis) of Qatar in 1981 to that in 1983?
Provide a short and direct response. 1.11. What is the ratio of the Pupil-teacher ratio(headcount basis) of OECD members in 1981 to that in 1984?
Your answer should be very brief. 1.01. What is the ratio of the Pupil-teacher ratio(headcount basis) of Israel in 1981 to that in 1984?
Keep it short and to the point. 0.97. What is the ratio of the Pupil-teacher ratio(headcount basis) of Myanmar in 1981 to that in 1984?
Your answer should be compact. 1.08. What is the ratio of the Pupil-teacher ratio(headcount basis) of Qatar in 1981 to that in 1984?
Keep it short and to the point. 1.1. What is the ratio of the Pupil-teacher ratio(headcount basis) of OECD members in 1982 to that in 1983?
Your answer should be compact. 1.01. What is the ratio of the Pupil-teacher ratio(headcount basis) of Myanmar in 1982 to that in 1983?
Your answer should be compact. 1.01. What is the ratio of the Pupil-teacher ratio(headcount basis) in Qatar in 1982 to that in 1983?
Your answer should be compact. 1.11. What is the ratio of the Pupil-teacher ratio(headcount basis) in OECD members in 1982 to that in 1984?
Keep it short and to the point. 1.01. What is the ratio of the Pupil-teacher ratio(headcount basis) of Israel in 1982 to that in 1984?
Offer a terse response. 1.02. What is the ratio of the Pupil-teacher ratio(headcount basis) in Myanmar in 1982 to that in 1984?
Ensure brevity in your answer.  1.09. What is the ratio of the Pupil-teacher ratio(headcount basis) in Qatar in 1982 to that in 1984?
Your answer should be compact. 1.1. What is the ratio of the Pupil-teacher ratio(headcount basis) in OECD members in 1983 to that in 1984?
Give a very brief answer. 1. What is the ratio of the Pupil-teacher ratio(headcount basis) of Israel in 1983 to that in 1984?
Provide a succinct answer. 1.02. What is the ratio of the Pupil-teacher ratio(headcount basis) in Myanmar in 1983 to that in 1984?
Offer a terse response. 1.07. What is the ratio of the Pupil-teacher ratio(headcount basis) of Qatar in 1983 to that in 1984?
Your answer should be very brief. 0.99. What is the difference between the highest and the second highest Pupil-teacher ratio(headcount basis) in OECD members?
Provide a succinct answer. 0.01. What is the difference between the highest and the second highest Pupil-teacher ratio(headcount basis) in Israel?
Provide a short and direct response. 0.04. What is the difference between the highest and the second highest Pupil-teacher ratio(headcount basis) of Myanmar?
Provide a succinct answer. 0.3. What is the difference between the highest and the second highest Pupil-teacher ratio(headcount basis) of Qatar?
Offer a very short reply. 0.16. What is the difference between the highest and the lowest Pupil-teacher ratio(headcount basis) of OECD members?
Ensure brevity in your answer.  0.32. What is the difference between the highest and the lowest Pupil-teacher ratio(headcount basis) of Israel?
Keep it short and to the point. 0.55. What is the difference between the highest and the lowest Pupil-teacher ratio(headcount basis) of Myanmar?
Give a very brief answer. 3.71. What is the difference between the highest and the lowest Pupil-teacher ratio(headcount basis) in Qatar?
Your answer should be very brief. 1.83. 